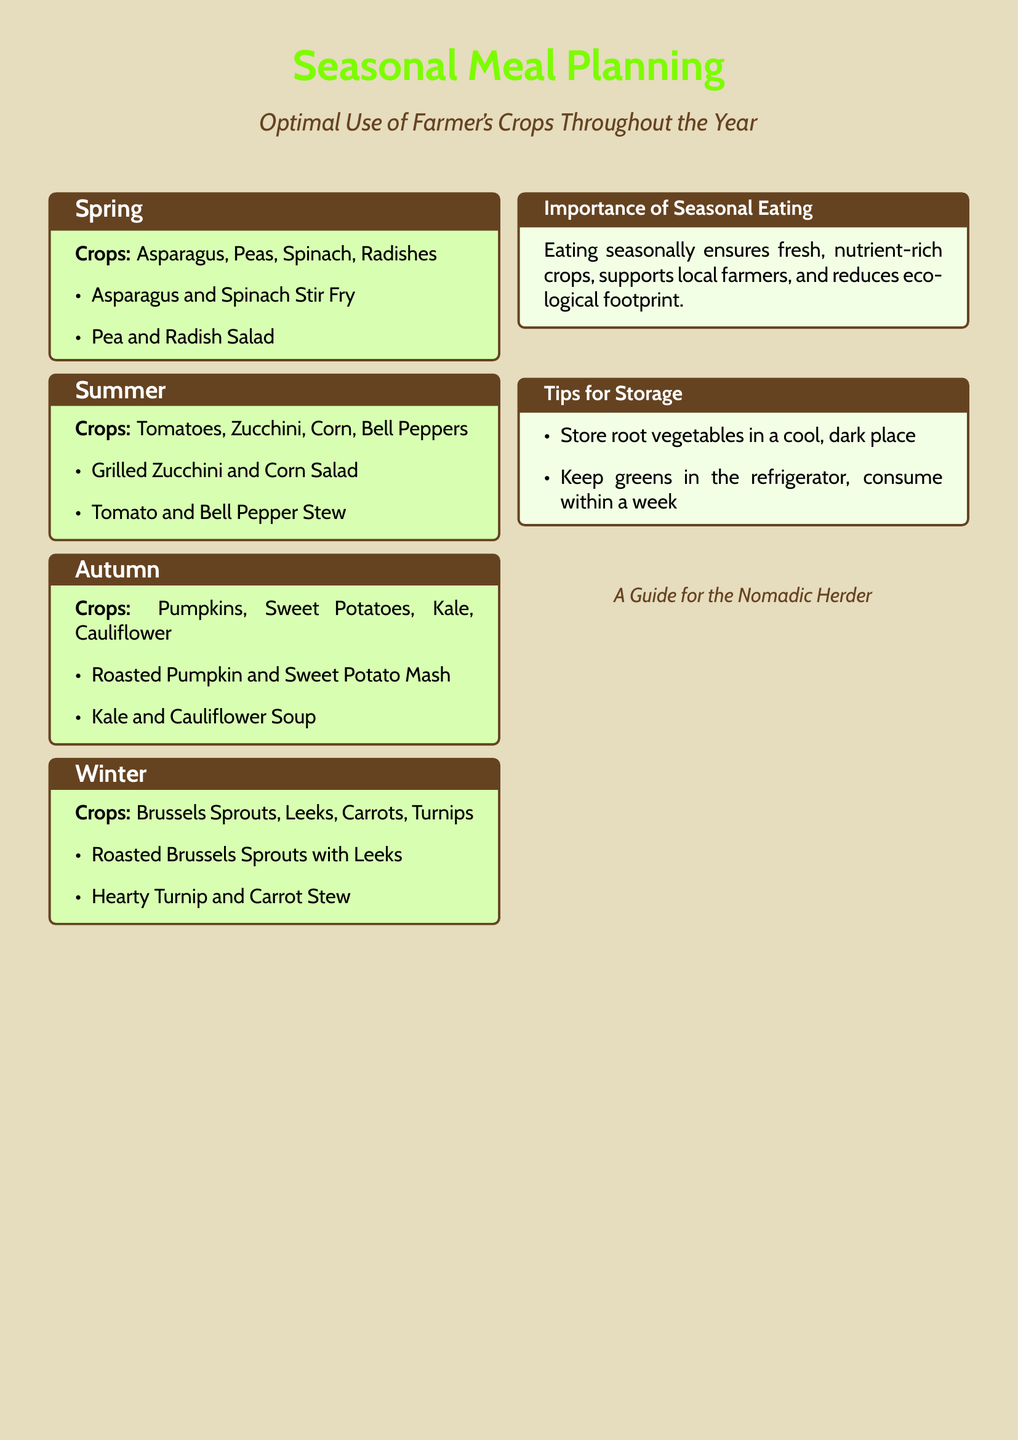What crops are available in spring? Spring includes asparagus, peas, spinach, and radishes as available crops.
Answer: Asparagus, Peas, Spinach, Radishes What is the first meal suggested for summer? The first meal suggested for summer using seasonal crops is grilled zucchini and corn salad.
Answer: Grilled Zucchini and Corn Salad Which vegetable is included in the autumn meal plan? The autumn season features crops such as pumpkins, sweet potatoes, kale, and cauliflower used in meal planning.
Answer: Pumpkins What is one benefit of eating seasonally? One benefit of eating seasonally highlighted in the document is that it ensures fresh, nutrient-rich crops.
Answer: Fresh, nutrient-rich crops How should root vegetables be stored? The document provides a tip that root vegetables should be stored in a cool, dark place for proper preservation.
Answer: Cool, dark place 